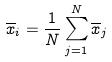<formula> <loc_0><loc_0><loc_500><loc_500>\overline { x } _ { i } = \frac { 1 } { N } \sum _ { j = 1 } ^ { N } \overline { x } _ { j }</formula> 